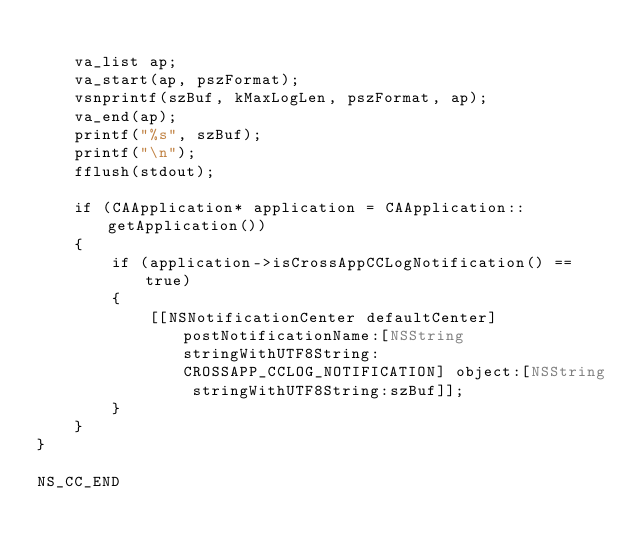<code> <loc_0><loc_0><loc_500><loc_500><_ObjectiveC_>
    va_list ap;
    va_start(ap, pszFormat);
    vsnprintf(szBuf, kMaxLogLen, pszFormat, ap);
    va_end(ap);
    printf("%s", szBuf);
    printf("\n");
    fflush(stdout);
    
    if (CAApplication* application = CAApplication::getApplication())
    {
        if (application->isCrossAppCCLogNotification() == true)
        {
            [[NSNotificationCenter defaultCenter] postNotificationName:[NSString stringWithUTF8String:CROSSAPP_CCLOG_NOTIFICATION] object:[NSString stringWithUTF8String:szBuf]];
        }
    }
}

NS_CC_END
</code> 